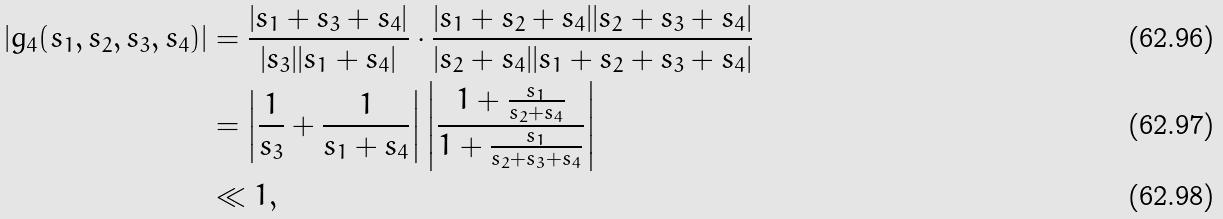<formula> <loc_0><loc_0><loc_500><loc_500>| g _ { 4 } ( s _ { 1 } , s _ { 2 } , s _ { 3 } , s _ { 4 } ) | & = \frac { | s _ { 1 } + s _ { 3 } + s _ { 4 } | } { | s _ { 3 } | | s _ { 1 } + s _ { 4 } | } \cdot \frac { | s _ { 1 } + s _ { 2 } + s _ { 4 } | | s _ { 2 } + s _ { 3 } + s _ { 4 } | } { | s _ { 2 } + s _ { 4 } | | s _ { 1 } + s _ { 2 } + s _ { 3 } + s _ { 4 } | } \\ & = \left | \frac { 1 } { s _ { 3 } } + \frac { 1 } { s _ { 1 } + s _ { 4 } } \right | \left | \frac { 1 + \frac { s _ { 1 } } { s _ { 2 } + s _ { 4 } } } { 1 + \frac { s _ { 1 } } { s _ { 2 } + s _ { 3 } + s _ { 4 } } } \right | \\ & \ll 1 ,</formula> 